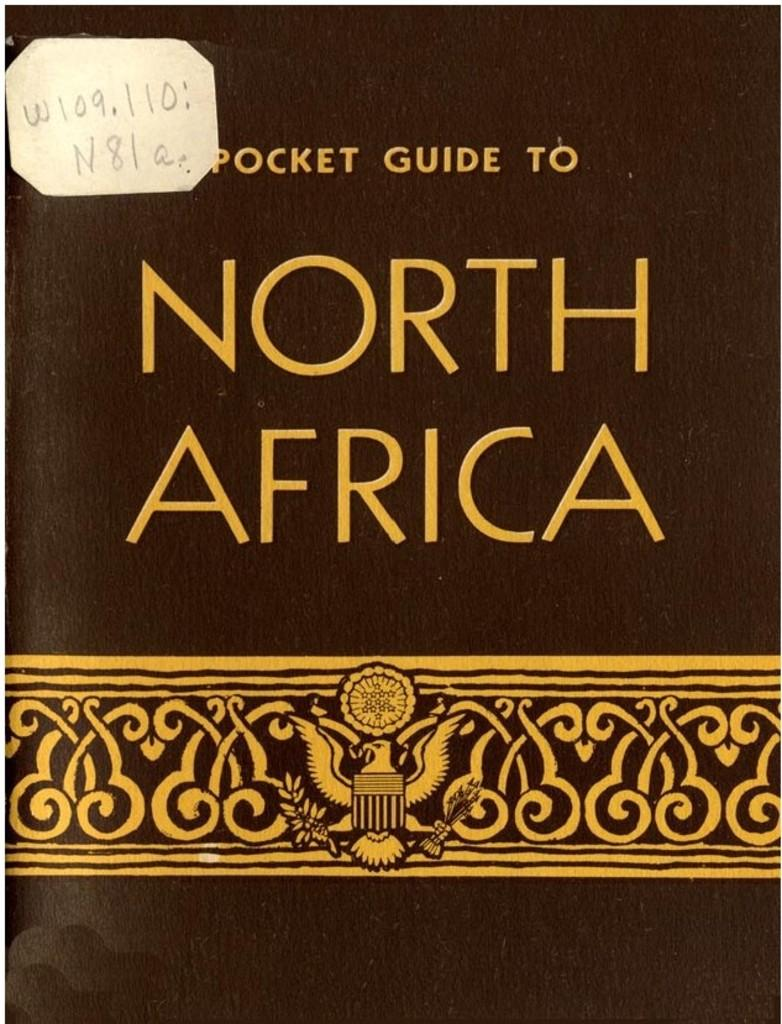<image>
Render a clear and concise summary of the photo. A small brown book named Pocket Guide to North Africa. 